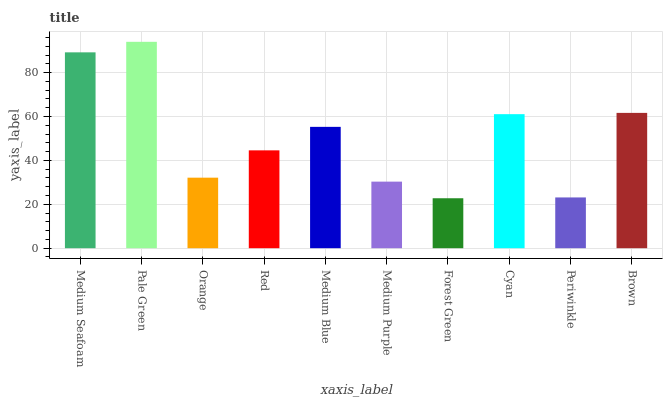Is Forest Green the minimum?
Answer yes or no. Yes. Is Pale Green the maximum?
Answer yes or no. Yes. Is Orange the minimum?
Answer yes or no. No. Is Orange the maximum?
Answer yes or no. No. Is Pale Green greater than Orange?
Answer yes or no. Yes. Is Orange less than Pale Green?
Answer yes or no. Yes. Is Orange greater than Pale Green?
Answer yes or no. No. Is Pale Green less than Orange?
Answer yes or no. No. Is Medium Blue the high median?
Answer yes or no. Yes. Is Red the low median?
Answer yes or no. Yes. Is Pale Green the high median?
Answer yes or no. No. Is Medium Purple the low median?
Answer yes or no. No. 